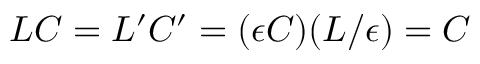Convert formula to latex. <formula><loc_0><loc_0><loc_500><loc_500>L C = L ^ { \prime } C ^ { \prime } = ( \epsilon C ) ( L / \epsilon ) = C</formula> 